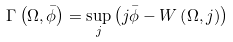<formula> <loc_0><loc_0><loc_500><loc_500>\Gamma \left ( \Omega , \bar { \phi } \right ) = \sup _ { j } \left ( j \bar { \phi } - W \left ( \Omega , j \right ) \right )</formula> 